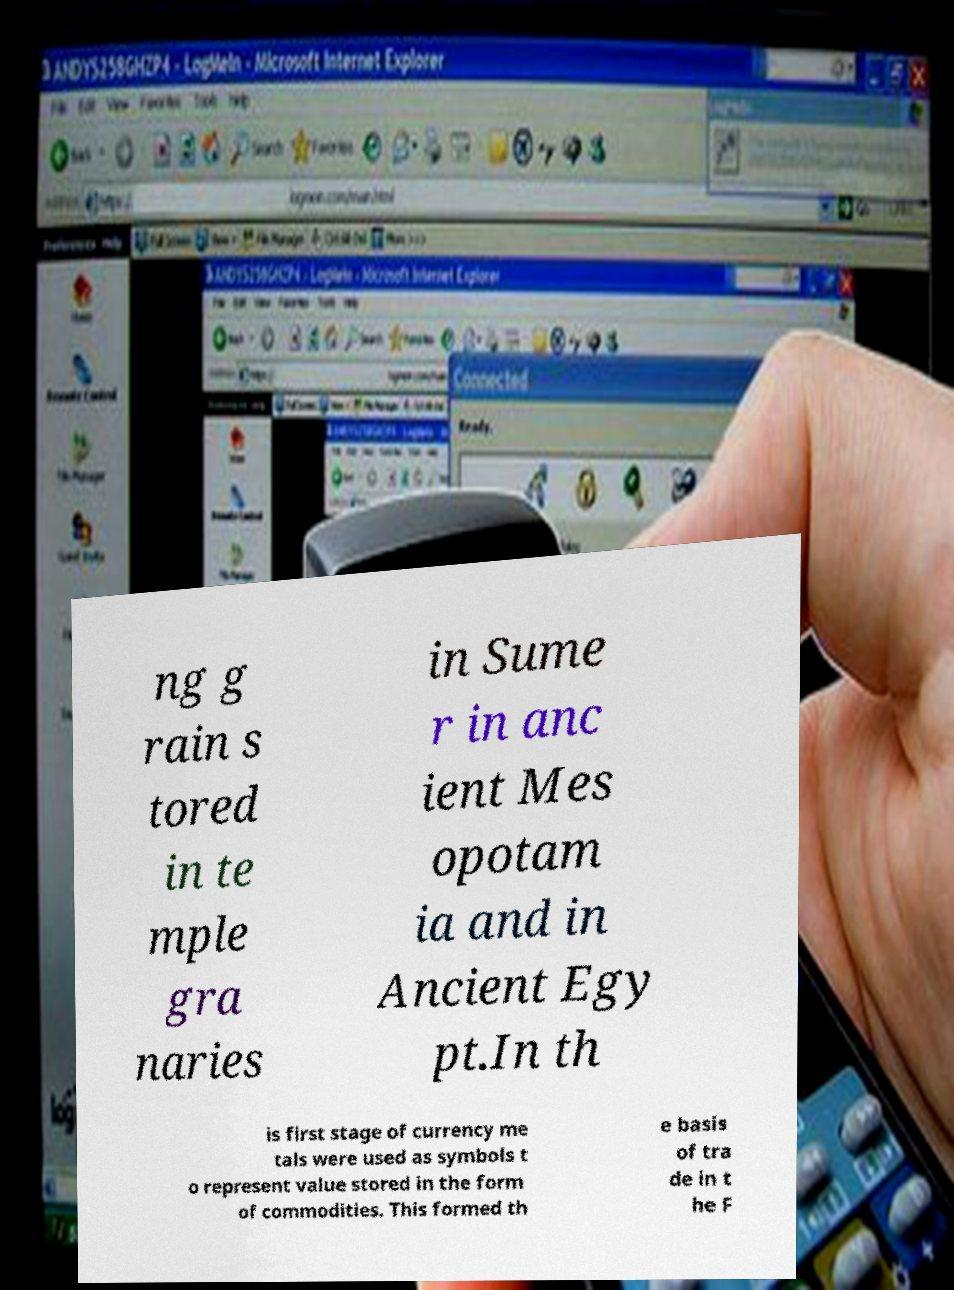Could you assist in decoding the text presented in this image and type it out clearly? ng g rain s tored in te mple gra naries in Sume r in anc ient Mes opotam ia and in Ancient Egy pt.In th is first stage of currency me tals were used as symbols t o represent value stored in the form of commodities. This formed th e basis of tra de in t he F 